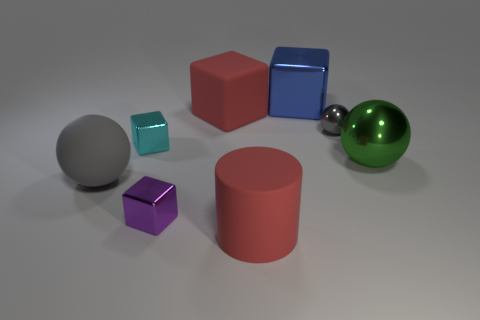Subtract 1 cubes. How many cubes are left? 3 Add 2 big matte cubes. How many objects exist? 10 Subtract all cylinders. How many objects are left? 7 Add 7 tiny gray metal spheres. How many tiny gray metal spheres exist? 8 Subtract 1 cyan cubes. How many objects are left? 7 Subtract all cyan shiny blocks. Subtract all small yellow matte cylinders. How many objects are left? 7 Add 3 rubber objects. How many rubber objects are left? 6 